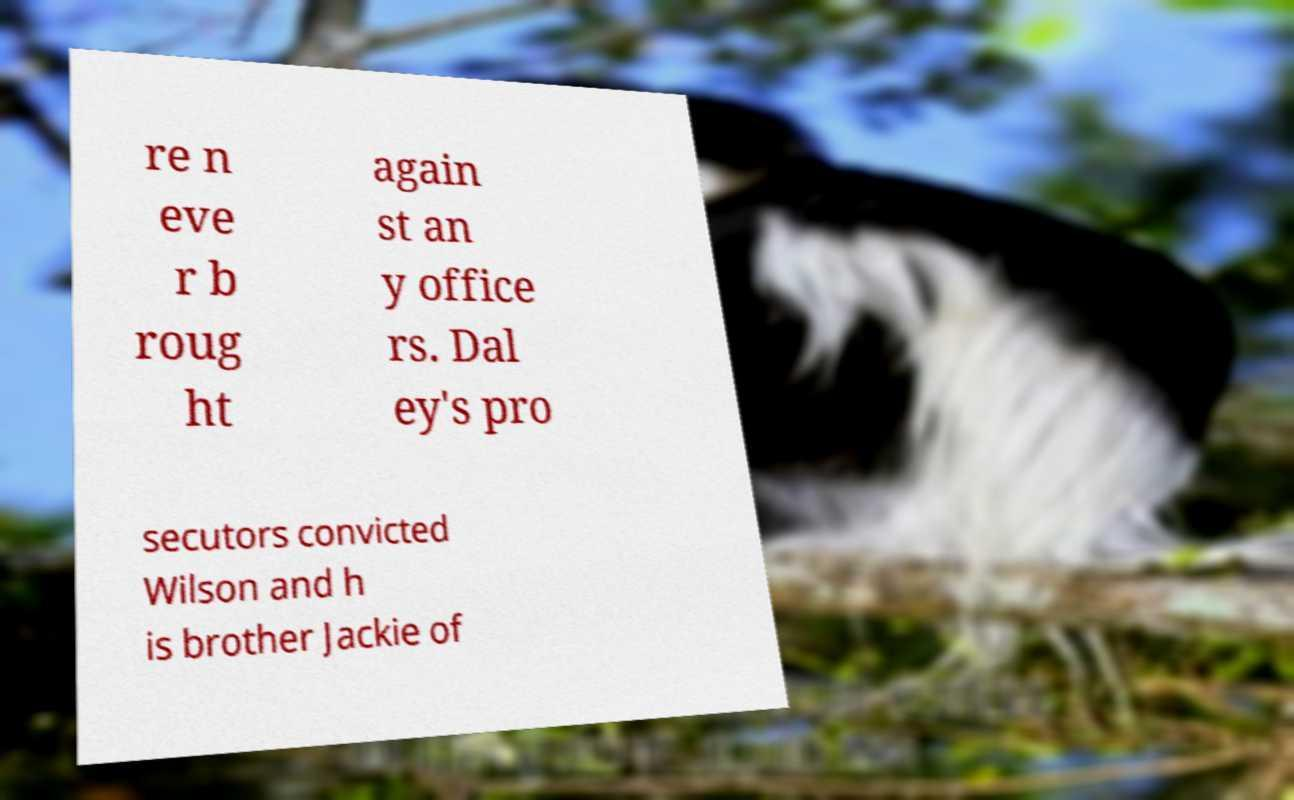Please read and relay the text visible in this image. What does it say? re n eve r b roug ht again st an y office rs. Dal ey's pro secutors convicted Wilson and h is brother Jackie of 